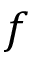<formula> <loc_0><loc_0><loc_500><loc_500>f</formula> 